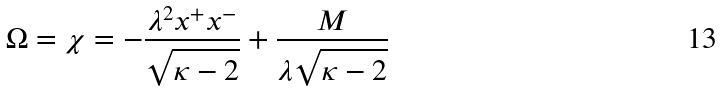<formula> <loc_0><loc_0><loc_500><loc_500>\Omega = \chi = - \frac { \lambda ^ { 2 } x ^ { + } x ^ { - } } { \sqrt { \kappa - 2 } } + \frac { M } { \lambda \sqrt { \kappa - 2 } }</formula> 